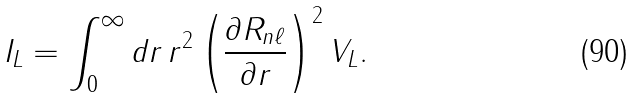<formula> <loc_0><loc_0><loc_500><loc_500>I _ { L } = \int _ { 0 } ^ { \infty } d r \, r ^ { 2 } \left ( \frac { \partial R _ { n \ell } } { \partial r } \right ) ^ { 2 } V _ { L } .</formula> 